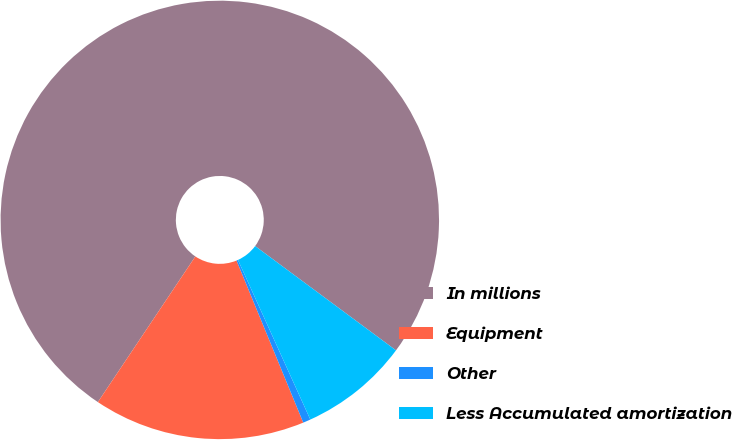<chart> <loc_0><loc_0><loc_500><loc_500><pie_chart><fcel>In millions<fcel>Equipment<fcel>Other<fcel>Less Accumulated amortization<nl><fcel>75.75%<fcel>15.6%<fcel>0.56%<fcel>8.08%<nl></chart> 